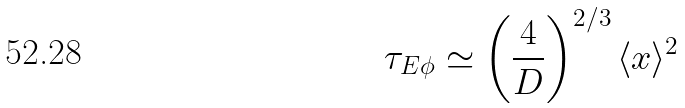<formula> <loc_0><loc_0><loc_500><loc_500>\tau _ { E \phi } \simeq \left ( \frac { 4 } { D } \right ) ^ { 2 / 3 } \langle x \rangle ^ { 2 }</formula> 